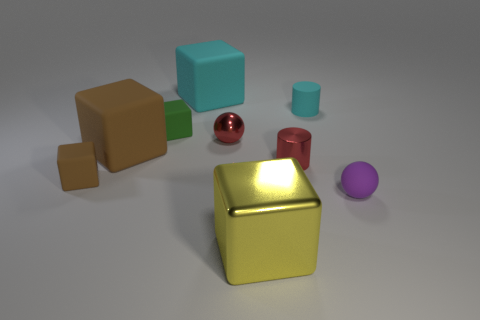Subtract all purple cubes. Subtract all green spheres. How many cubes are left? 5 Add 1 tiny cyan metal cylinders. How many objects exist? 10 Subtract all cylinders. How many objects are left? 7 Subtract 0 green spheres. How many objects are left? 9 Subtract all purple rubber objects. Subtract all large objects. How many objects are left? 5 Add 2 tiny cubes. How many tiny cubes are left? 4 Add 9 big metal things. How many big metal things exist? 10 